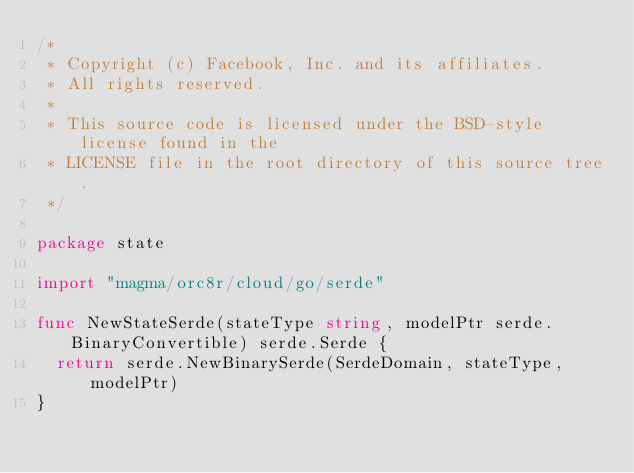Convert code to text. <code><loc_0><loc_0><loc_500><loc_500><_Go_>/*
 * Copyright (c) Facebook, Inc. and its affiliates.
 * All rights reserved.
 *
 * This source code is licensed under the BSD-style license found in the
 * LICENSE file in the root directory of this source tree.
 */

package state

import "magma/orc8r/cloud/go/serde"

func NewStateSerde(stateType string, modelPtr serde.BinaryConvertible) serde.Serde {
	return serde.NewBinarySerde(SerdeDomain, stateType, modelPtr)
}
</code> 